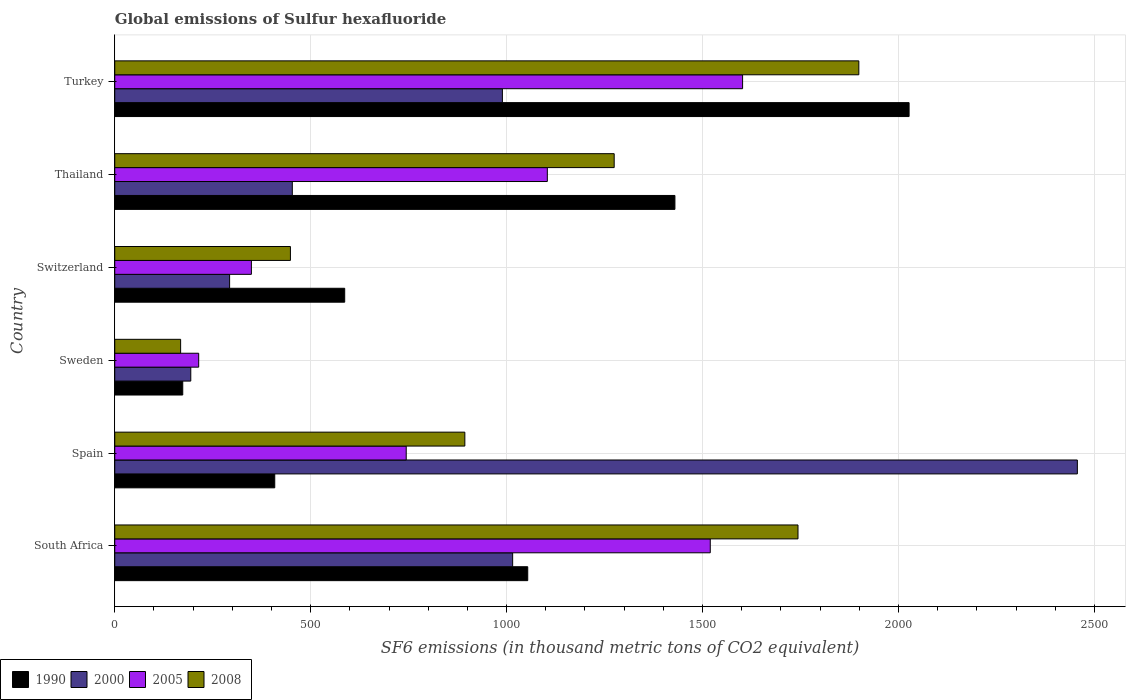How many different coloured bars are there?
Offer a very short reply. 4. Are the number of bars per tick equal to the number of legend labels?
Keep it short and to the point. Yes. How many bars are there on the 3rd tick from the bottom?
Keep it short and to the point. 4. What is the label of the 2nd group of bars from the top?
Your response must be concise. Thailand. In how many cases, is the number of bars for a given country not equal to the number of legend labels?
Offer a very short reply. 0. What is the global emissions of Sulfur hexafluoride in 2000 in Turkey?
Provide a short and direct response. 989.2. Across all countries, what is the maximum global emissions of Sulfur hexafluoride in 2000?
Your answer should be compact. 2456.5. Across all countries, what is the minimum global emissions of Sulfur hexafluoride in 2000?
Offer a terse response. 194. In which country was the global emissions of Sulfur hexafluoride in 2008 minimum?
Offer a terse response. Sweden. What is the total global emissions of Sulfur hexafluoride in 2008 in the graph?
Your response must be concise. 6426.7. What is the difference between the global emissions of Sulfur hexafluoride in 2008 in Thailand and that in Turkey?
Your response must be concise. -624.3. What is the difference between the global emissions of Sulfur hexafluoride in 2008 in Sweden and the global emissions of Sulfur hexafluoride in 1990 in Spain?
Make the answer very short. -240.2. What is the average global emissions of Sulfur hexafluoride in 2008 per country?
Make the answer very short. 1071.12. What is the difference between the global emissions of Sulfur hexafluoride in 1990 and global emissions of Sulfur hexafluoride in 2005 in Thailand?
Offer a very short reply. 325.6. In how many countries, is the global emissions of Sulfur hexafluoride in 2008 greater than 1800 thousand metric tons?
Your response must be concise. 1. What is the ratio of the global emissions of Sulfur hexafluoride in 1990 in Spain to that in Thailand?
Provide a short and direct response. 0.29. Is the global emissions of Sulfur hexafluoride in 2000 in South Africa less than that in Switzerland?
Offer a terse response. No. Is the difference between the global emissions of Sulfur hexafluoride in 1990 in Spain and Sweden greater than the difference between the global emissions of Sulfur hexafluoride in 2005 in Spain and Sweden?
Your answer should be very brief. No. What is the difference between the highest and the second highest global emissions of Sulfur hexafluoride in 1990?
Give a very brief answer. 597.6. What is the difference between the highest and the lowest global emissions of Sulfur hexafluoride in 2005?
Your response must be concise. 1388. Is the sum of the global emissions of Sulfur hexafluoride in 2000 in Thailand and Turkey greater than the maximum global emissions of Sulfur hexafluoride in 2008 across all countries?
Your response must be concise. No. Is it the case that in every country, the sum of the global emissions of Sulfur hexafluoride in 1990 and global emissions of Sulfur hexafluoride in 2005 is greater than the sum of global emissions of Sulfur hexafluoride in 2000 and global emissions of Sulfur hexafluoride in 2008?
Your answer should be compact. No. What does the 2nd bar from the top in Sweden represents?
Provide a short and direct response. 2005. Is it the case that in every country, the sum of the global emissions of Sulfur hexafluoride in 2000 and global emissions of Sulfur hexafluoride in 1990 is greater than the global emissions of Sulfur hexafluoride in 2005?
Offer a very short reply. Yes. Are all the bars in the graph horizontal?
Make the answer very short. Yes. Are the values on the major ticks of X-axis written in scientific E-notation?
Your answer should be very brief. No. Does the graph contain any zero values?
Offer a terse response. No. How are the legend labels stacked?
Offer a terse response. Horizontal. What is the title of the graph?
Provide a succinct answer. Global emissions of Sulfur hexafluoride. Does "1975" appear as one of the legend labels in the graph?
Keep it short and to the point. No. What is the label or title of the X-axis?
Your answer should be compact. SF6 emissions (in thousand metric tons of CO2 equivalent). What is the label or title of the Y-axis?
Ensure brevity in your answer.  Country. What is the SF6 emissions (in thousand metric tons of CO2 equivalent) in 1990 in South Africa?
Your answer should be very brief. 1053.9. What is the SF6 emissions (in thousand metric tons of CO2 equivalent) of 2000 in South Africa?
Make the answer very short. 1015.4. What is the SF6 emissions (in thousand metric tons of CO2 equivalent) of 2005 in South Africa?
Provide a succinct answer. 1519.7. What is the SF6 emissions (in thousand metric tons of CO2 equivalent) in 2008 in South Africa?
Ensure brevity in your answer.  1743.6. What is the SF6 emissions (in thousand metric tons of CO2 equivalent) of 1990 in Spain?
Ensure brevity in your answer.  408.3. What is the SF6 emissions (in thousand metric tons of CO2 equivalent) of 2000 in Spain?
Give a very brief answer. 2456.5. What is the SF6 emissions (in thousand metric tons of CO2 equivalent) of 2005 in Spain?
Keep it short and to the point. 743.8. What is the SF6 emissions (in thousand metric tons of CO2 equivalent) in 2008 in Spain?
Offer a terse response. 893.4. What is the SF6 emissions (in thousand metric tons of CO2 equivalent) of 1990 in Sweden?
Offer a terse response. 173.5. What is the SF6 emissions (in thousand metric tons of CO2 equivalent) in 2000 in Sweden?
Give a very brief answer. 194. What is the SF6 emissions (in thousand metric tons of CO2 equivalent) in 2005 in Sweden?
Keep it short and to the point. 214.2. What is the SF6 emissions (in thousand metric tons of CO2 equivalent) of 2008 in Sweden?
Your answer should be very brief. 168.1. What is the SF6 emissions (in thousand metric tons of CO2 equivalent) in 1990 in Switzerland?
Provide a short and direct response. 586.8. What is the SF6 emissions (in thousand metric tons of CO2 equivalent) in 2000 in Switzerland?
Your answer should be very brief. 293.1. What is the SF6 emissions (in thousand metric tons of CO2 equivalent) in 2005 in Switzerland?
Provide a short and direct response. 348.7. What is the SF6 emissions (in thousand metric tons of CO2 equivalent) of 2008 in Switzerland?
Make the answer very short. 448.3. What is the SF6 emissions (in thousand metric tons of CO2 equivalent) of 1990 in Thailand?
Keep it short and to the point. 1429.5. What is the SF6 emissions (in thousand metric tons of CO2 equivalent) of 2000 in Thailand?
Your response must be concise. 453.1. What is the SF6 emissions (in thousand metric tons of CO2 equivalent) in 2005 in Thailand?
Your response must be concise. 1103.9. What is the SF6 emissions (in thousand metric tons of CO2 equivalent) of 2008 in Thailand?
Your answer should be compact. 1274.5. What is the SF6 emissions (in thousand metric tons of CO2 equivalent) of 1990 in Turkey?
Your answer should be very brief. 2027.1. What is the SF6 emissions (in thousand metric tons of CO2 equivalent) of 2000 in Turkey?
Ensure brevity in your answer.  989.2. What is the SF6 emissions (in thousand metric tons of CO2 equivalent) of 2005 in Turkey?
Your answer should be compact. 1602.2. What is the SF6 emissions (in thousand metric tons of CO2 equivalent) in 2008 in Turkey?
Your response must be concise. 1898.8. Across all countries, what is the maximum SF6 emissions (in thousand metric tons of CO2 equivalent) of 1990?
Make the answer very short. 2027.1. Across all countries, what is the maximum SF6 emissions (in thousand metric tons of CO2 equivalent) in 2000?
Provide a short and direct response. 2456.5. Across all countries, what is the maximum SF6 emissions (in thousand metric tons of CO2 equivalent) of 2005?
Ensure brevity in your answer.  1602.2. Across all countries, what is the maximum SF6 emissions (in thousand metric tons of CO2 equivalent) in 2008?
Your answer should be very brief. 1898.8. Across all countries, what is the minimum SF6 emissions (in thousand metric tons of CO2 equivalent) of 1990?
Provide a short and direct response. 173.5. Across all countries, what is the minimum SF6 emissions (in thousand metric tons of CO2 equivalent) in 2000?
Provide a succinct answer. 194. Across all countries, what is the minimum SF6 emissions (in thousand metric tons of CO2 equivalent) in 2005?
Your answer should be very brief. 214.2. Across all countries, what is the minimum SF6 emissions (in thousand metric tons of CO2 equivalent) in 2008?
Keep it short and to the point. 168.1. What is the total SF6 emissions (in thousand metric tons of CO2 equivalent) of 1990 in the graph?
Provide a short and direct response. 5679.1. What is the total SF6 emissions (in thousand metric tons of CO2 equivalent) in 2000 in the graph?
Provide a succinct answer. 5401.3. What is the total SF6 emissions (in thousand metric tons of CO2 equivalent) of 2005 in the graph?
Provide a succinct answer. 5532.5. What is the total SF6 emissions (in thousand metric tons of CO2 equivalent) in 2008 in the graph?
Your answer should be very brief. 6426.7. What is the difference between the SF6 emissions (in thousand metric tons of CO2 equivalent) of 1990 in South Africa and that in Spain?
Give a very brief answer. 645.6. What is the difference between the SF6 emissions (in thousand metric tons of CO2 equivalent) of 2000 in South Africa and that in Spain?
Provide a short and direct response. -1441.1. What is the difference between the SF6 emissions (in thousand metric tons of CO2 equivalent) of 2005 in South Africa and that in Spain?
Make the answer very short. 775.9. What is the difference between the SF6 emissions (in thousand metric tons of CO2 equivalent) in 2008 in South Africa and that in Spain?
Ensure brevity in your answer.  850.2. What is the difference between the SF6 emissions (in thousand metric tons of CO2 equivalent) of 1990 in South Africa and that in Sweden?
Give a very brief answer. 880.4. What is the difference between the SF6 emissions (in thousand metric tons of CO2 equivalent) in 2000 in South Africa and that in Sweden?
Offer a very short reply. 821.4. What is the difference between the SF6 emissions (in thousand metric tons of CO2 equivalent) in 2005 in South Africa and that in Sweden?
Your response must be concise. 1305.5. What is the difference between the SF6 emissions (in thousand metric tons of CO2 equivalent) of 2008 in South Africa and that in Sweden?
Make the answer very short. 1575.5. What is the difference between the SF6 emissions (in thousand metric tons of CO2 equivalent) of 1990 in South Africa and that in Switzerland?
Your response must be concise. 467.1. What is the difference between the SF6 emissions (in thousand metric tons of CO2 equivalent) of 2000 in South Africa and that in Switzerland?
Offer a terse response. 722.3. What is the difference between the SF6 emissions (in thousand metric tons of CO2 equivalent) in 2005 in South Africa and that in Switzerland?
Your response must be concise. 1171. What is the difference between the SF6 emissions (in thousand metric tons of CO2 equivalent) of 2008 in South Africa and that in Switzerland?
Ensure brevity in your answer.  1295.3. What is the difference between the SF6 emissions (in thousand metric tons of CO2 equivalent) of 1990 in South Africa and that in Thailand?
Your answer should be very brief. -375.6. What is the difference between the SF6 emissions (in thousand metric tons of CO2 equivalent) in 2000 in South Africa and that in Thailand?
Your answer should be compact. 562.3. What is the difference between the SF6 emissions (in thousand metric tons of CO2 equivalent) of 2005 in South Africa and that in Thailand?
Keep it short and to the point. 415.8. What is the difference between the SF6 emissions (in thousand metric tons of CO2 equivalent) of 2008 in South Africa and that in Thailand?
Make the answer very short. 469.1. What is the difference between the SF6 emissions (in thousand metric tons of CO2 equivalent) in 1990 in South Africa and that in Turkey?
Your answer should be compact. -973.2. What is the difference between the SF6 emissions (in thousand metric tons of CO2 equivalent) of 2000 in South Africa and that in Turkey?
Keep it short and to the point. 26.2. What is the difference between the SF6 emissions (in thousand metric tons of CO2 equivalent) in 2005 in South Africa and that in Turkey?
Offer a very short reply. -82.5. What is the difference between the SF6 emissions (in thousand metric tons of CO2 equivalent) of 2008 in South Africa and that in Turkey?
Provide a succinct answer. -155.2. What is the difference between the SF6 emissions (in thousand metric tons of CO2 equivalent) in 1990 in Spain and that in Sweden?
Ensure brevity in your answer.  234.8. What is the difference between the SF6 emissions (in thousand metric tons of CO2 equivalent) in 2000 in Spain and that in Sweden?
Your answer should be very brief. 2262.5. What is the difference between the SF6 emissions (in thousand metric tons of CO2 equivalent) of 2005 in Spain and that in Sweden?
Offer a very short reply. 529.6. What is the difference between the SF6 emissions (in thousand metric tons of CO2 equivalent) in 2008 in Spain and that in Sweden?
Offer a very short reply. 725.3. What is the difference between the SF6 emissions (in thousand metric tons of CO2 equivalent) of 1990 in Spain and that in Switzerland?
Your response must be concise. -178.5. What is the difference between the SF6 emissions (in thousand metric tons of CO2 equivalent) in 2000 in Spain and that in Switzerland?
Keep it short and to the point. 2163.4. What is the difference between the SF6 emissions (in thousand metric tons of CO2 equivalent) of 2005 in Spain and that in Switzerland?
Give a very brief answer. 395.1. What is the difference between the SF6 emissions (in thousand metric tons of CO2 equivalent) of 2008 in Spain and that in Switzerland?
Ensure brevity in your answer.  445.1. What is the difference between the SF6 emissions (in thousand metric tons of CO2 equivalent) in 1990 in Spain and that in Thailand?
Provide a succinct answer. -1021.2. What is the difference between the SF6 emissions (in thousand metric tons of CO2 equivalent) of 2000 in Spain and that in Thailand?
Provide a succinct answer. 2003.4. What is the difference between the SF6 emissions (in thousand metric tons of CO2 equivalent) in 2005 in Spain and that in Thailand?
Your response must be concise. -360.1. What is the difference between the SF6 emissions (in thousand metric tons of CO2 equivalent) in 2008 in Spain and that in Thailand?
Your answer should be compact. -381.1. What is the difference between the SF6 emissions (in thousand metric tons of CO2 equivalent) of 1990 in Spain and that in Turkey?
Your answer should be very brief. -1618.8. What is the difference between the SF6 emissions (in thousand metric tons of CO2 equivalent) in 2000 in Spain and that in Turkey?
Provide a short and direct response. 1467.3. What is the difference between the SF6 emissions (in thousand metric tons of CO2 equivalent) in 2005 in Spain and that in Turkey?
Keep it short and to the point. -858.4. What is the difference between the SF6 emissions (in thousand metric tons of CO2 equivalent) in 2008 in Spain and that in Turkey?
Provide a short and direct response. -1005.4. What is the difference between the SF6 emissions (in thousand metric tons of CO2 equivalent) of 1990 in Sweden and that in Switzerland?
Keep it short and to the point. -413.3. What is the difference between the SF6 emissions (in thousand metric tons of CO2 equivalent) in 2000 in Sweden and that in Switzerland?
Your response must be concise. -99.1. What is the difference between the SF6 emissions (in thousand metric tons of CO2 equivalent) of 2005 in Sweden and that in Switzerland?
Give a very brief answer. -134.5. What is the difference between the SF6 emissions (in thousand metric tons of CO2 equivalent) in 2008 in Sweden and that in Switzerland?
Give a very brief answer. -280.2. What is the difference between the SF6 emissions (in thousand metric tons of CO2 equivalent) of 1990 in Sweden and that in Thailand?
Make the answer very short. -1256. What is the difference between the SF6 emissions (in thousand metric tons of CO2 equivalent) of 2000 in Sweden and that in Thailand?
Offer a terse response. -259.1. What is the difference between the SF6 emissions (in thousand metric tons of CO2 equivalent) of 2005 in Sweden and that in Thailand?
Make the answer very short. -889.7. What is the difference between the SF6 emissions (in thousand metric tons of CO2 equivalent) of 2008 in Sweden and that in Thailand?
Your answer should be very brief. -1106.4. What is the difference between the SF6 emissions (in thousand metric tons of CO2 equivalent) in 1990 in Sweden and that in Turkey?
Ensure brevity in your answer.  -1853.6. What is the difference between the SF6 emissions (in thousand metric tons of CO2 equivalent) of 2000 in Sweden and that in Turkey?
Your answer should be compact. -795.2. What is the difference between the SF6 emissions (in thousand metric tons of CO2 equivalent) of 2005 in Sweden and that in Turkey?
Your answer should be compact. -1388. What is the difference between the SF6 emissions (in thousand metric tons of CO2 equivalent) of 2008 in Sweden and that in Turkey?
Your answer should be compact. -1730.7. What is the difference between the SF6 emissions (in thousand metric tons of CO2 equivalent) of 1990 in Switzerland and that in Thailand?
Keep it short and to the point. -842.7. What is the difference between the SF6 emissions (in thousand metric tons of CO2 equivalent) of 2000 in Switzerland and that in Thailand?
Your answer should be compact. -160. What is the difference between the SF6 emissions (in thousand metric tons of CO2 equivalent) in 2005 in Switzerland and that in Thailand?
Offer a very short reply. -755.2. What is the difference between the SF6 emissions (in thousand metric tons of CO2 equivalent) in 2008 in Switzerland and that in Thailand?
Your response must be concise. -826.2. What is the difference between the SF6 emissions (in thousand metric tons of CO2 equivalent) in 1990 in Switzerland and that in Turkey?
Your answer should be very brief. -1440.3. What is the difference between the SF6 emissions (in thousand metric tons of CO2 equivalent) in 2000 in Switzerland and that in Turkey?
Offer a very short reply. -696.1. What is the difference between the SF6 emissions (in thousand metric tons of CO2 equivalent) of 2005 in Switzerland and that in Turkey?
Give a very brief answer. -1253.5. What is the difference between the SF6 emissions (in thousand metric tons of CO2 equivalent) of 2008 in Switzerland and that in Turkey?
Provide a short and direct response. -1450.5. What is the difference between the SF6 emissions (in thousand metric tons of CO2 equivalent) of 1990 in Thailand and that in Turkey?
Make the answer very short. -597.6. What is the difference between the SF6 emissions (in thousand metric tons of CO2 equivalent) of 2000 in Thailand and that in Turkey?
Offer a very short reply. -536.1. What is the difference between the SF6 emissions (in thousand metric tons of CO2 equivalent) in 2005 in Thailand and that in Turkey?
Give a very brief answer. -498.3. What is the difference between the SF6 emissions (in thousand metric tons of CO2 equivalent) of 2008 in Thailand and that in Turkey?
Ensure brevity in your answer.  -624.3. What is the difference between the SF6 emissions (in thousand metric tons of CO2 equivalent) of 1990 in South Africa and the SF6 emissions (in thousand metric tons of CO2 equivalent) of 2000 in Spain?
Give a very brief answer. -1402.6. What is the difference between the SF6 emissions (in thousand metric tons of CO2 equivalent) in 1990 in South Africa and the SF6 emissions (in thousand metric tons of CO2 equivalent) in 2005 in Spain?
Give a very brief answer. 310.1. What is the difference between the SF6 emissions (in thousand metric tons of CO2 equivalent) of 1990 in South Africa and the SF6 emissions (in thousand metric tons of CO2 equivalent) of 2008 in Spain?
Your answer should be very brief. 160.5. What is the difference between the SF6 emissions (in thousand metric tons of CO2 equivalent) of 2000 in South Africa and the SF6 emissions (in thousand metric tons of CO2 equivalent) of 2005 in Spain?
Keep it short and to the point. 271.6. What is the difference between the SF6 emissions (in thousand metric tons of CO2 equivalent) of 2000 in South Africa and the SF6 emissions (in thousand metric tons of CO2 equivalent) of 2008 in Spain?
Your answer should be very brief. 122. What is the difference between the SF6 emissions (in thousand metric tons of CO2 equivalent) of 2005 in South Africa and the SF6 emissions (in thousand metric tons of CO2 equivalent) of 2008 in Spain?
Your answer should be very brief. 626.3. What is the difference between the SF6 emissions (in thousand metric tons of CO2 equivalent) of 1990 in South Africa and the SF6 emissions (in thousand metric tons of CO2 equivalent) of 2000 in Sweden?
Make the answer very short. 859.9. What is the difference between the SF6 emissions (in thousand metric tons of CO2 equivalent) of 1990 in South Africa and the SF6 emissions (in thousand metric tons of CO2 equivalent) of 2005 in Sweden?
Offer a very short reply. 839.7. What is the difference between the SF6 emissions (in thousand metric tons of CO2 equivalent) of 1990 in South Africa and the SF6 emissions (in thousand metric tons of CO2 equivalent) of 2008 in Sweden?
Your answer should be compact. 885.8. What is the difference between the SF6 emissions (in thousand metric tons of CO2 equivalent) in 2000 in South Africa and the SF6 emissions (in thousand metric tons of CO2 equivalent) in 2005 in Sweden?
Offer a terse response. 801.2. What is the difference between the SF6 emissions (in thousand metric tons of CO2 equivalent) in 2000 in South Africa and the SF6 emissions (in thousand metric tons of CO2 equivalent) in 2008 in Sweden?
Provide a short and direct response. 847.3. What is the difference between the SF6 emissions (in thousand metric tons of CO2 equivalent) of 2005 in South Africa and the SF6 emissions (in thousand metric tons of CO2 equivalent) of 2008 in Sweden?
Provide a short and direct response. 1351.6. What is the difference between the SF6 emissions (in thousand metric tons of CO2 equivalent) of 1990 in South Africa and the SF6 emissions (in thousand metric tons of CO2 equivalent) of 2000 in Switzerland?
Keep it short and to the point. 760.8. What is the difference between the SF6 emissions (in thousand metric tons of CO2 equivalent) of 1990 in South Africa and the SF6 emissions (in thousand metric tons of CO2 equivalent) of 2005 in Switzerland?
Your answer should be very brief. 705.2. What is the difference between the SF6 emissions (in thousand metric tons of CO2 equivalent) of 1990 in South Africa and the SF6 emissions (in thousand metric tons of CO2 equivalent) of 2008 in Switzerland?
Make the answer very short. 605.6. What is the difference between the SF6 emissions (in thousand metric tons of CO2 equivalent) of 2000 in South Africa and the SF6 emissions (in thousand metric tons of CO2 equivalent) of 2005 in Switzerland?
Provide a short and direct response. 666.7. What is the difference between the SF6 emissions (in thousand metric tons of CO2 equivalent) in 2000 in South Africa and the SF6 emissions (in thousand metric tons of CO2 equivalent) in 2008 in Switzerland?
Offer a very short reply. 567.1. What is the difference between the SF6 emissions (in thousand metric tons of CO2 equivalent) in 2005 in South Africa and the SF6 emissions (in thousand metric tons of CO2 equivalent) in 2008 in Switzerland?
Make the answer very short. 1071.4. What is the difference between the SF6 emissions (in thousand metric tons of CO2 equivalent) of 1990 in South Africa and the SF6 emissions (in thousand metric tons of CO2 equivalent) of 2000 in Thailand?
Offer a terse response. 600.8. What is the difference between the SF6 emissions (in thousand metric tons of CO2 equivalent) of 1990 in South Africa and the SF6 emissions (in thousand metric tons of CO2 equivalent) of 2008 in Thailand?
Provide a short and direct response. -220.6. What is the difference between the SF6 emissions (in thousand metric tons of CO2 equivalent) in 2000 in South Africa and the SF6 emissions (in thousand metric tons of CO2 equivalent) in 2005 in Thailand?
Offer a terse response. -88.5. What is the difference between the SF6 emissions (in thousand metric tons of CO2 equivalent) in 2000 in South Africa and the SF6 emissions (in thousand metric tons of CO2 equivalent) in 2008 in Thailand?
Ensure brevity in your answer.  -259.1. What is the difference between the SF6 emissions (in thousand metric tons of CO2 equivalent) of 2005 in South Africa and the SF6 emissions (in thousand metric tons of CO2 equivalent) of 2008 in Thailand?
Provide a succinct answer. 245.2. What is the difference between the SF6 emissions (in thousand metric tons of CO2 equivalent) of 1990 in South Africa and the SF6 emissions (in thousand metric tons of CO2 equivalent) of 2000 in Turkey?
Your answer should be very brief. 64.7. What is the difference between the SF6 emissions (in thousand metric tons of CO2 equivalent) of 1990 in South Africa and the SF6 emissions (in thousand metric tons of CO2 equivalent) of 2005 in Turkey?
Provide a succinct answer. -548.3. What is the difference between the SF6 emissions (in thousand metric tons of CO2 equivalent) of 1990 in South Africa and the SF6 emissions (in thousand metric tons of CO2 equivalent) of 2008 in Turkey?
Provide a short and direct response. -844.9. What is the difference between the SF6 emissions (in thousand metric tons of CO2 equivalent) of 2000 in South Africa and the SF6 emissions (in thousand metric tons of CO2 equivalent) of 2005 in Turkey?
Provide a succinct answer. -586.8. What is the difference between the SF6 emissions (in thousand metric tons of CO2 equivalent) of 2000 in South Africa and the SF6 emissions (in thousand metric tons of CO2 equivalent) of 2008 in Turkey?
Make the answer very short. -883.4. What is the difference between the SF6 emissions (in thousand metric tons of CO2 equivalent) in 2005 in South Africa and the SF6 emissions (in thousand metric tons of CO2 equivalent) in 2008 in Turkey?
Your answer should be compact. -379.1. What is the difference between the SF6 emissions (in thousand metric tons of CO2 equivalent) in 1990 in Spain and the SF6 emissions (in thousand metric tons of CO2 equivalent) in 2000 in Sweden?
Your answer should be compact. 214.3. What is the difference between the SF6 emissions (in thousand metric tons of CO2 equivalent) of 1990 in Spain and the SF6 emissions (in thousand metric tons of CO2 equivalent) of 2005 in Sweden?
Offer a very short reply. 194.1. What is the difference between the SF6 emissions (in thousand metric tons of CO2 equivalent) of 1990 in Spain and the SF6 emissions (in thousand metric tons of CO2 equivalent) of 2008 in Sweden?
Offer a very short reply. 240.2. What is the difference between the SF6 emissions (in thousand metric tons of CO2 equivalent) of 2000 in Spain and the SF6 emissions (in thousand metric tons of CO2 equivalent) of 2005 in Sweden?
Provide a short and direct response. 2242.3. What is the difference between the SF6 emissions (in thousand metric tons of CO2 equivalent) in 2000 in Spain and the SF6 emissions (in thousand metric tons of CO2 equivalent) in 2008 in Sweden?
Your answer should be compact. 2288.4. What is the difference between the SF6 emissions (in thousand metric tons of CO2 equivalent) of 2005 in Spain and the SF6 emissions (in thousand metric tons of CO2 equivalent) of 2008 in Sweden?
Your answer should be compact. 575.7. What is the difference between the SF6 emissions (in thousand metric tons of CO2 equivalent) of 1990 in Spain and the SF6 emissions (in thousand metric tons of CO2 equivalent) of 2000 in Switzerland?
Give a very brief answer. 115.2. What is the difference between the SF6 emissions (in thousand metric tons of CO2 equivalent) in 1990 in Spain and the SF6 emissions (in thousand metric tons of CO2 equivalent) in 2005 in Switzerland?
Give a very brief answer. 59.6. What is the difference between the SF6 emissions (in thousand metric tons of CO2 equivalent) of 2000 in Spain and the SF6 emissions (in thousand metric tons of CO2 equivalent) of 2005 in Switzerland?
Give a very brief answer. 2107.8. What is the difference between the SF6 emissions (in thousand metric tons of CO2 equivalent) of 2000 in Spain and the SF6 emissions (in thousand metric tons of CO2 equivalent) of 2008 in Switzerland?
Your answer should be compact. 2008.2. What is the difference between the SF6 emissions (in thousand metric tons of CO2 equivalent) of 2005 in Spain and the SF6 emissions (in thousand metric tons of CO2 equivalent) of 2008 in Switzerland?
Keep it short and to the point. 295.5. What is the difference between the SF6 emissions (in thousand metric tons of CO2 equivalent) of 1990 in Spain and the SF6 emissions (in thousand metric tons of CO2 equivalent) of 2000 in Thailand?
Offer a terse response. -44.8. What is the difference between the SF6 emissions (in thousand metric tons of CO2 equivalent) of 1990 in Spain and the SF6 emissions (in thousand metric tons of CO2 equivalent) of 2005 in Thailand?
Make the answer very short. -695.6. What is the difference between the SF6 emissions (in thousand metric tons of CO2 equivalent) of 1990 in Spain and the SF6 emissions (in thousand metric tons of CO2 equivalent) of 2008 in Thailand?
Offer a very short reply. -866.2. What is the difference between the SF6 emissions (in thousand metric tons of CO2 equivalent) in 2000 in Spain and the SF6 emissions (in thousand metric tons of CO2 equivalent) in 2005 in Thailand?
Give a very brief answer. 1352.6. What is the difference between the SF6 emissions (in thousand metric tons of CO2 equivalent) in 2000 in Spain and the SF6 emissions (in thousand metric tons of CO2 equivalent) in 2008 in Thailand?
Your answer should be very brief. 1182. What is the difference between the SF6 emissions (in thousand metric tons of CO2 equivalent) of 2005 in Spain and the SF6 emissions (in thousand metric tons of CO2 equivalent) of 2008 in Thailand?
Provide a short and direct response. -530.7. What is the difference between the SF6 emissions (in thousand metric tons of CO2 equivalent) in 1990 in Spain and the SF6 emissions (in thousand metric tons of CO2 equivalent) in 2000 in Turkey?
Keep it short and to the point. -580.9. What is the difference between the SF6 emissions (in thousand metric tons of CO2 equivalent) in 1990 in Spain and the SF6 emissions (in thousand metric tons of CO2 equivalent) in 2005 in Turkey?
Provide a succinct answer. -1193.9. What is the difference between the SF6 emissions (in thousand metric tons of CO2 equivalent) in 1990 in Spain and the SF6 emissions (in thousand metric tons of CO2 equivalent) in 2008 in Turkey?
Your response must be concise. -1490.5. What is the difference between the SF6 emissions (in thousand metric tons of CO2 equivalent) of 2000 in Spain and the SF6 emissions (in thousand metric tons of CO2 equivalent) of 2005 in Turkey?
Your answer should be very brief. 854.3. What is the difference between the SF6 emissions (in thousand metric tons of CO2 equivalent) of 2000 in Spain and the SF6 emissions (in thousand metric tons of CO2 equivalent) of 2008 in Turkey?
Give a very brief answer. 557.7. What is the difference between the SF6 emissions (in thousand metric tons of CO2 equivalent) in 2005 in Spain and the SF6 emissions (in thousand metric tons of CO2 equivalent) in 2008 in Turkey?
Make the answer very short. -1155. What is the difference between the SF6 emissions (in thousand metric tons of CO2 equivalent) in 1990 in Sweden and the SF6 emissions (in thousand metric tons of CO2 equivalent) in 2000 in Switzerland?
Provide a short and direct response. -119.6. What is the difference between the SF6 emissions (in thousand metric tons of CO2 equivalent) in 1990 in Sweden and the SF6 emissions (in thousand metric tons of CO2 equivalent) in 2005 in Switzerland?
Ensure brevity in your answer.  -175.2. What is the difference between the SF6 emissions (in thousand metric tons of CO2 equivalent) of 1990 in Sweden and the SF6 emissions (in thousand metric tons of CO2 equivalent) of 2008 in Switzerland?
Keep it short and to the point. -274.8. What is the difference between the SF6 emissions (in thousand metric tons of CO2 equivalent) in 2000 in Sweden and the SF6 emissions (in thousand metric tons of CO2 equivalent) in 2005 in Switzerland?
Provide a succinct answer. -154.7. What is the difference between the SF6 emissions (in thousand metric tons of CO2 equivalent) of 2000 in Sweden and the SF6 emissions (in thousand metric tons of CO2 equivalent) of 2008 in Switzerland?
Make the answer very short. -254.3. What is the difference between the SF6 emissions (in thousand metric tons of CO2 equivalent) in 2005 in Sweden and the SF6 emissions (in thousand metric tons of CO2 equivalent) in 2008 in Switzerland?
Offer a terse response. -234.1. What is the difference between the SF6 emissions (in thousand metric tons of CO2 equivalent) of 1990 in Sweden and the SF6 emissions (in thousand metric tons of CO2 equivalent) of 2000 in Thailand?
Make the answer very short. -279.6. What is the difference between the SF6 emissions (in thousand metric tons of CO2 equivalent) in 1990 in Sweden and the SF6 emissions (in thousand metric tons of CO2 equivalent) in 2005 in Thailand?
Ensure brevity in your answer.  -930.4. What is the difference between the SF6 emissions (in thousand metric tons of CO2 equivalent) of 1990 in Sweden and the SF6 emissions (in thousand metric tons of CO2 equivalent) of 2008 in Thailand?
Provide a short and direct response. -1101. What is the difference between the SF6 emissions (in thousand metric tons of CO2 equivalent) in 2000 in Sweden and the SF6 emissions (in thousand metric tons of CO2 equivalent) in 2005 in Thailand?
Provide a short and direct response. -909.9. What is the difference between the SF6 emissions (in thousand metric tons of CO2 equivalent) in 2000 in Sweden and the SF6 emissions (in thousand metric tons of CO2 equivalent) in 2008 in Thailand?
Your answer should be very brief. -1080.5. What is the difference between the SF6 emissions (in thousand metric tons of CO2 equivalent) of 2005 in Sweden and the SF6 emissions (in thousand metric tons of CO2 equivalent) of 2008 in Thailand?
Give a very brief answer. -1060.3. What is the difference between the SF6 emissions (in thousand metric tons of CO2 equivalent) of 1990 in Sweden and the SF6 emissions (in thousand metric tons of CO2 equivalent) of 2000 in Turkey?
Your response must be concise. -815.7. What is the difference between the SF6 emissions (in thousand metric tons of CO2 equivalent) in 1990 in Sweden and the SF6 emissions (in thousand metric tons of CO2 equivalent) in 2005 in Turkey?
Your answer should be very brief. -1428.7. What is the difference between the SF6 emissions (in thousand metric tons of CO2 equivalent) of 1990 in Sweden and the SF6 emissions (in thousand metric tons of CO2 equivalent) of 2008 in Turkey?
Ensure brevity in your answer.  -1725.3. What is the difference between the SF6 emissions (in thousand metric tons of CO2 equivalent) of 2000 in Sweden and the SF6 emissions (in thousand metric tons of CO2 equivalent) of 2005 in Turkey?
Keep it short and to the point. -1408.2. What is the difference between the SF6 emissions (in thousand metric tons of CO2 equivalent) in 2000 in Sweden and the SF6 emissions (in thousand metric tons of CO2 equivalent) in 2008 in Turkey?
Your answer should be compact. -1704.8. What is the difference between the SF6 emissions (in thousand metric tons of CO2 equivalent) of 2005 in Sweden and the SF6 emissions (in thousand metric tons of CO2 equivalent) of 2008 in Turkey?
Your response must be concise. -1684.6. What is the difference between the SF6 emissions (in thousand metric tons of CO2 equivalent) in 1990 in Switzerland and the SF6 emissions (in thousand metric tons of CO2 equivalent) in 2000 in Thailand?
Ensure brevity in your answer.  133.7. What is the difference between the SF6 emissions (in thousand metric tons of CO2 equivalent) in 1990 in Switzerland and the SF6 emissions (in thousand metric tons of CO2 equivalent) in 2005 in Thailand?
Provide a short and direct response. -517.1. What is the difference between the SF6 emissions (in thousand metric tons of CO2 equivalent) in 1990 in Switzerland and the SF6 emissions (in thousand metric tons of CO2 equivalent) in 2008 in Thailand?
Ensure brevity in your answer.  -687.7. What is the difference between the SF6 emissions (in thousand metric tons of CO2 equivalent) in 2000 in Switzerland and the SF6 emissions (in thousand metric tons of CO2 equivalent) in 2005 in Thailand?
Offer a very short reply. -810.8. What is the difference between the SF6 emissions (in thousand metric tons of CO2 equivalent) in 2000 in Switzerland and the SF6 emissions (in thousand metric tons of CO2 equivalent) in 2008 in Thailand?
Keep it short and to the point. -981.4. What is the difference between the SF6 emissions (in thousand metric tons of CO2 equivalent) in 2005 in Switzerland and the SF6 emissions (in thousand metric tons of CO2 equivalent) in 2008 in Thailand?
Provide a succinct answer. -925.8. What is the difference between the SF6 emissions (in thousand metric tons of CO2 equivalent) of 1990 in Switzerland and the SF6 emissions (in thousand metric tons of CO2 equivalent) of 2000 in Turkey?
Your response must be concise. -402.4. What is the difference between the SF6 emissions (in thousand metric tons of CO2 equivalent) in 1990 in Switzerland and the SF6 emissions (in thousand metric tons of CO2 equivalent) in 2005 in Turkey?
Your response must be concise. -1015.4. What is the difference between the SF6 emissions (in thousand metric tons of CO2 equivalent) of 1990 in Switzerland and the SF6 emissions (in thousand metric tons of CO2 equivalent) of 2008 in Turkey?
Keep it short and to the point. -1312. What is the difference between the SF6 emissions (in thousand metric tons of CO2 equivalent) of 2000 in Switzerland and the SF6 emissions (in thousand metric tons of CO2 equivalent) of 2005 in Turkey?
Ensure brevity in your answer.  -1309.1. What is the difference between the SF6 emissions (in thousand metric tons of CO2 equivalent) of 2000 in Switzerland and the SF6 emissions (in thousand metric tons of CO2 equivalent) of 2008 in Turkey?
Offer a terse response. -1605.7. What is the difference between the SF6 emissions (in thousand metric tons of CO2 equivalent) in 2005 in Switzerland and the SF6 emissions (in thousand metric tons of CO2 equivalent) in 2008 in Turkey?
Provide a short and direct response. -1550.1. What is the difference between the SF6 emissions (in thousand metric tons of CO2 equivalent) of 1990 in Thailand and the SF6 emissions (in thousand metric tons of CO2 equivalent) of 2000 in Turkey?
Your answer should be very brief. 440.3. What is the difference between the SF6 emissions (in thousand metric tons of CO2 equivalent) of 1990 in Thailand and the SF6 emissions (in thousand metric tons of CO2 equivalent) of 2005 in Turkey?
Your response must be concise. -172.7. What is the difference between the SF6 emissions (in thousand metric tons of CO2 equivalent) of 1990 in Thailand and the SF6 emissions (in thousand metric tons of CO2 equivalent) of 2008 in Turkey?
Provide a succinct answer. -469.3. What is the difference between the SF6 emissions (in thousand metric tons of CO2 equivalent) in 2000 in Thailand and the SF6 emissions (in thousand metric tons of CO2 equivalent) in 2005 in Turkey?
Keep it short and to the point. -1149.1. What is the difference between the SF6 emissions (in thousand metric tons of CO2 equivalent) of 2000 in Thailand and the SF6 emissions (in thousand metric tons of CO2 equivalent) of 2008 in Turkey?
Provide a succinct answer. -1445.7. What is the difference between the SF6 emissions (in thousand metric tons of CO2 equivalent) of 2005 in Thailand and the SF6 emissions (in thousand metric tons of CO2 equivalent) of 2008 in Turkey?
Keep it short and to the point. -794.9. What is the average SF6 emissions (in thousand metric tons of CO2 equivalent) of 1990 per country?
Ensure brevity in your answer.  946.52. What is the average SF6 emissions (in thousand metric tons of CO2 equivalent) in 2000 per country?
Offer a terse response. 900.22. What is the average SF6 emissions (in thousand metric tons of CO2 equivalent) of 2005 per country?
Give a very brief answer. 922.08. What is the average SF6 emissions (in thousand metric tons of CO2 equivalent) of 2008 per country?
Ensure brevity in your answer.  1071.12. What is the difference between the SF6 emissions (in thousand metric tons of CO2 equivalent) in 1990 and SF6 emissions (in thousand metric tons of CO2 equivalent) in 2000 in South Africa?
Offer a terse response. 38.5. What is the difference between the SF6 emissions (in thousand metric tons of CO2 equivalent) of 1990 and SF6 emissions (in thousand metric tons of CO2 equivalent) of 2005 in South Africa?
Ensure brevity in your answer.  -465.8. What is the difference between the SF6 emissions (in thousand metric tons of CO2 equivalent) in 1990 and SF6 emissions (in thousand metric tons of CO2 equivalent) in 2008 in South Africa?
Your answer should be compact. -689.7. What is the difference between the SF6 emissions (in thousand metric tons of CO2 equivalent) of 2000 and SF6 emissions (in thousand metric tons of CO2 equivalent) of 2005 in South Africa?
Your answer should be very brief. -504.3. What is the difference between the SF6 emissions (in thousand metric tons of CO2 equivalent) in 2000 and SF6 emissions (in thousand metric tons of CO2 equivalent) in 2008 in South Africa?
Offer a terse response. -728.2. What is the difference between the SF6 emissions (in thousand metric tons of CO2 equivalent) in 2005 and SF6 emissions (in thousand metric tons of CO2 equivalent) in 2008 in South Africa?
Your answer should be very brief. -223.9. What is the difference between the SF6 emissions (in thousand metric tons of CO2 equivalent) in 1990 and SF6 emissions (in thousand metric tons of CO2 equivalent) in 2000 in Spain?
Keep it short and to the point. -2048.2. What is the difference between the SF6 emissions (in thousand metric tons of CO2 equivalent) in 1990 and SF6 emissions (in thousand metric tons of CO2 equivalent) in 2005 in Spain?
Your response must be concise. -335.5. What is the difference between the SF6 emissions (in thousand metric tons of CO2 equivalent) of 1990 and SF6 emissions (in thousand metric tons of CO2 equivalent) of 2008 in Spain?
Make the answer very short. -485.1. What is the difference between the SF6 emissions (in thousand metric tons of CO2 equivalent) in 2000 and SF6 emissions (in thousand metric tons of CO2 equivalent) in 2005 in Spain?
Your answer should be very brief. 1712.7. What is the difference between the SF6 emissions (in thousand metric tons of CO2 equivalent) of 2000 and SF6 emissions (in thousand metric tons of CO2 equivalent) of 2008 in Spain?
Keep it short and to the point. 1563.1. What is the difference between the SF6 emissions (in thousand metric tons of CO2 equivalent) of 2005 and SF6 emissions (in thousand metric tons of CO2 equivalent) of 2008 in Spain?
Keep it short and to the point. -149.6. What is the difference between the SF6 emissions (in thousand metric tons of CO2 equivalent) in 1990 and SF6 emissions (in thousand metric tons of CO2 equivalent) in 2000 in Sweden?
Make the answer very short. -20.5. What is the difference between the SF6 emissions (in thousand metric tons of CO2 equivalent) in 1990 and SF6 emissions (in thousand metric tons of CO2 equivalent) in 2005 in Sweden?
Provide a succinct answer. -40.7. What is the difference between the SF6 emissions (in thousand metric tons of CO2 equivalent) in 2000 and SF6 emissions (in thousand metric tons of CO2 equivalent) in 2005 in Sweden?
Ensure brevity in your answer.  -20.2. What is the difference between the SF6 emissions (in thousand metric tons of CO2 equivalent) in 2000 and SF6 emissions (in thousand metric tons of CO2 equivalent) in 2008 in Sweden?
Make the answer very short. 25.9. What is the difference between the SF6 emissions (in thousand metric tons of CO2 equivalent) of 2005 and SF6 emissions (in thousand metric tons of CO2 equivalent) of 2008 in Sweden?
Give a very brief answer. 46.1. What is the difference between the SF6 emissions (in thousand metric tons of CO2 equivalent) of 1990 and SF6 emissions (in thousand metric tons of CO2 equivalent) of 2000 in Switzerland?
Offer a terse response. 293.7. What is the difference between the SF6 emissions (in thousand metric tons of CO2 equivalent) of 1990 and SF6 emissions (in thousand metric tons of CO2 equivalent) of 2005 in Switzerland?
Provide a short and direct response. 238.1. What is the difference between the SF6 emissions (in thousand metric tons of CO2 equivalent) of 1990 and SF6 emissions (in thousand metric tons of CO2 equivalent) of 2008 in Switzerland?
Your answer should be very brief. 138.5. What is the difference between the SF6 emissions (in thousand metric tons of CO2 equivalent) of 2000 and SF6 emissions (in thousand metric tons of CO2 equivalent) of 2005 in Switzerland?
Provide a short and direct response. -55.6. What is the difference between the SF6 emissions (in thousand metric tons of CO2 equivalent) of 2000 and SF6 emissions (in thousand metric tons of CO2 equivalent) of 2008 in Switzerland?
Give a very brief answer. -155.2. What is the difference between the SF6 emissions (in thousand metric tons of CO2 equivalent) of 2005 and SF6 emissions (in thousand metric tons of CO2 equivalent) of 2008 in Switzerland?
Give a very brief answer. -99.6. What is the difference between the SF6 emissions (in thousand metric tons of CO2 equivalent) in 1990 and SF6 emissions (in thousand metric tons of CO2 equivalent) in 2000 in Thailand?
Your answer should be compact. 976.4. What is the difference between the SF6 emissions (in thousand metric tons of CO2 equivalent) in 1990 and SF6 emissions (in thousand metric tons of CO2 equivalent) in 2005 in Thailand?
Make the answer very short. 325.6. What is the difference between the SF6 emissions (in thousand metric tons of CO2 equivalent) in 1990 and SF6 emissions (in thousand metric tons of CO2 equivalent) in 2008 in Thailand?
Give a very brief answer. 155. What is the difference between the SF6 emissions (in thousand metric tons of CO2 equivalent) in 2000 and SF6 emissions (in thousand metric tons of CO2 equivalent) in 2005 in Thailand?
Your answer should be compact. -650.8. What is the difference between the SF6 emissions (in thousand metric tons of CO2 equivalent) in 2000 and SF6 emissions (in thousand metric tons of CO2 equivalent) in 2008 in Thailand?
Keep it short and to the point. -821.4. What is the difference between the SF6 emissions (in thousand metric tons of CO2 equivalent) in 2005 and SF6 emissions (in thousand metric tons of CO2 equivalent) in 2008 in Thailand?
Provide a short and direct response. -170.6. What is the difference between the SF6 emissions (in thousand metric tons of CO2 equivalent) in 1990 and SF6 emissions (in thousand metric tons of CO2 equivalent) in 2000 in Turkey?
Your answer should be compact. 1037.9. What is the difference between the SF6 emissions (in thousand metric tons of CO2 equivalent) of 1990 and SF6 emissions (in thousand metric tons of CO2 equivalent) of 2005 in Turkey?
Your answer should be compact. 424.9. What is the difference between the SF6 emissions (in thousand metric tons of CO2 equivalent) in 1990 and SF6 emissions (in thousand metric tons of CO2 equivalent) in 2008 in Turkey?
Your answer should be compact. 128.3. What is the difference between the SF6 emissions (in thousand metric tons of CO2 equivalent) in 2000 and SF6 emissions (in thousand metric tons of CO2 equivalent) in 2005 in Turkey?
Offer a terse response. -613. What is the difference between the SF6 emissions (in thousand metric tons of CO2 equivalent) of 2000 and SF6 emissions (in thousand metric tons of CO2 equivalent) of 2008 in Turkey?
Provide a succinct answer. -909.6. What is the difference between the SF6 emissions (in thousand metric tons of CO2 equivalent) in 2005 and SF6 emissions (in thousand metric tons of CO2 equivalent) in 2008 in Turkey?
Ensure brevity in your answer.  -296.6. What is the ratio of the SF6 emissions (in thousand metric tons of CO2 equivalent) of 1990 in South Africa to that in Spain?
Your answer should be very brief. 2.58. What is the ratio of the SF6 emissions (in thousand metric tons of CO2 equivalent) of 2000 in South Africa to that in Spain?
Offer a terse response. 0.41. What is the ratio of the SF6 emissions (in thousand metric tons of CO2 equivalent) in 2005 in South Africa to that in Spain?
Provide a short and direct response. 2.04. What is the ratio of the SF6 emissions (in thousand metric tons of CO2 equivalent) of 2008 in South Africa to that in Spain?
Ensure brevity in your answer.  1.95. What is the ratio of the SF6 emissions (in thousand metric tons of CO2 equivalent) in 1990 in South Africa to that in Sweden?
Provide a short and direct response. 6.07. What is the ratio of the SF6 emissions (in thousand metric tons of CO2 equivalent) of 2000 in South Africa to that in Sweden?
Offer a terse response. 5.23. What is the ratio of the SF6 emissions (in thousand metric tons of CO2 equivalent) in 2005 in South Africa to that in Sweden?
Your response must be concise. 7.09. What is the ratio of the SF6 emissions (in thousand metric tons of CO2 equivalent) in 2008 in South Africa to that in Sweden?
Provide a succinct answer. 10.37. What is the ratio of the SF6 emissions (in thousand metric tons of CO2 equivalent) of 1990 in South Africa to that in Switzerland?
Make the answer very short. 1.8. What is the ratio of the SF6 emissions (in thousand metric tons of CO2 equivalent) in 2000 in South Africa to that in Switzerland?
Give a very brief answer. 3.46. What is the ratio of the SF6 emissions (in thousand metric tons of CO2 equivalent) of 2005 in South Africa to that in Switzerland?
Provide a succinct answer. 4.36. What is the ratio of the SF6 emissions (in thousand metric tons of CO2 equivalent) in 2008 in South Africa to that in Switzerland?
Ensure brevity in your answer.  3.89. What is the ratio of the SF6 emissions (in thousand metric tons of CO2 equivalent) in 1990 in South Africa to that in Thailand?
Offer a very short reply. 0.74. What is the ratio of the SF6 emissions (in thousand metric tons of CO2 equivalent) in 2000 in South Africa to that in Thailand?
Make the answer very short. 2.24. What is the ratio of the SF6 emissions (in thousand metric tons of CO2 equivalent) in 2005 in South Africa to that in Thailand?
Make the answer very short. 1.38. What is the ratio of the SF6 emissions (in thousand metric tons of CO2 equivalent) in 2008 in South Africa to that in Thailand?
Your answer should be very brief. 1.37. What is the ratio of the SF6 emissions (in thousand metric tons of CO2 equivalent) in 1990 in South Africa to that in Turkey?
Your answer should be compact. 0.52. What is the ratio of the SF6 emissions (in thousand metric tons of CO2 equivalent) of 2000 in South Africa to that in Turkey?
Your answer should be compact. 1.03. What is the ratio of the SF6 emissions (in thousand metric tons of CO2 equivalent) of 2005 in South Africa to that in Turkey?
Offer a very short reply. 0.95. What is the ratio of the SF6 emissions (in thousand metric tons of CO2 equivalent) of 2008 in South Africa to that in Turkey?
Ensure brevity in your answer.  0.92. What is the ratio of the SF6 emissions (in thousand metric tons of CO2 equivalent) in 1990 in Spain to that in Sweden?
Your response must be concise. 2.35. What is the ratio of the SF6 emissions (in thousand metric tons of CO2 equivalent) in 2000 in Spain to that in Sweden?
Make the answer very short. 12.66. What is the ratio of the SF6 emissions (in thousand metric tons of CO2 equivalent) in 2005 in Spain to that in Sweden?
Give a very brief answer. 3.47. What is the ratio of the SF6 emissions (in thousand metric tons of CO2 equivalent) of 2008 in Spain to that in Sweden?
Offer a terse response. 5.31. What is the ratio of the SF6 emissions (in thousand metric tons of CO2 equivalent) in 1990 in Spain to that in Switzerland?
Keep it short and to the point. 0.7. What is the ratio of the SF6 emissions (in thousand metric tons of CO2 equivalent) of 2000 in Spain to that in Switzerland?
Your answer should be very brief. 8.38. What is the ratio of the SF6 emissions (in thousand metric tons of CO2 equivalent) of 2005 in Spain to that in Switzerland?
Offer a very short reply. 2.13. What is the ratio of the SF6 emissions (in thousand metric tons of CO2 equivalent) in 2008 in Spain to that in Switzerland?
Provide a short and direct response. 1.99. What is the ratio of the SF6 emissions (in thousand metric tons of CO2 equivalent) of 1990 in Spain to that in Thailand?
Keep it short and to the point. 0.29. What is the ratio of the SF6 emissions (in thousand metric tons of CO2 equivalent) of 2000 in Spain to that in Thailand?
Give a very brief answer. 5.42. What is the ratio of the SF6 emissions (in thousand metric tons of CO2 equivalent) in 2005 in Spain to that in Thailand?
Offer a terse response. 0.67. What is the ratio of the SF6 emissions (in thousand metric tons of CO2 equivalent) in 2008 in Spain to that in Thailand?
Keep it short and to the point. 0.7. What is the ratio of the SF6 emissions (in thousand metric tons of CO2 equivalent) in 1990 in Spain to that in Turkey?
Provide a short and direct response. 0.2. What is the ratio of the SF6 emissions (in thousand metric tons of CO2 equivalent) of 2000 in Spain to that in Turkey?
Ensure brevity in your answer.  2.48. What is the ratio of the SF6 emissions (in thousand metric tons of CO2 equivalent) in 2005 in Spain to that in Turkey?
Ensure brevity in your answer.  0.46. What is the ratio of the SF6 emissions (in thousand metric tons of CO2 equivalent) in 2008 in Spain to that in Turkey?
Offer a very short reply. 0.47. What is the ratio of the SF6 emissions (in thousand metric tons of CO2 equivalent) in 1990 in Sweden to that in Switzerland?
Offer a terse response. 0.3. What is the ratio of the SF6 emissions (in thousand metric tons of CO2 equivalent) of 2000 in Sweden to that in Switzerland?
Provide a short and direct response. 0.66. What is the ratio of the SF6 emissions (in thousand metric tons of CO2 equivalent) of 2005 in Sweden to that in Switzerland?
Give a very brief answer. 0.61. What is the ratio of the SF6 emissions (in thousand metric tons of CO2 equivalent) of 1990 in Sweden to that in Thailand?
Give a very brief answer. 0.12. What is the ratio of the SF6 emissions (in thousand metric tons of CO2 equivalent) in 2000 in Sweden to that in Thailand?
Provide a succinct answer. 0.43. What is the ratio of the SF6 emissions (in thousand metric tons of CO2 equivalent) of 2005 in Sweden to that in Thailand?
Make the answer very short. 0.19. What is the ratio of the SF6 emissions (in thousand metric tons of CO2 equivalent) of 2008 in Sweden to that in Thailand?
Provide a succinct answer. 0.13. What is the ratio of the SF6 emissions (in thousand metric tons of CO2 equivalent) in 1990 in Sweden to that in Turkey?
Give a very brief answer. 0.09. What is the ratio of the SF6 emissions (in thousand metric tons of CO2 equivalent) of 2000 in Sweden to that in Turkey?
Make the answer very short. 0.2. What is the ratio of the SF6 emissions (in thousand metric tons of CO2 equivalent) in 2005 in Sweden to that in Turkey?
Provide a succinct answer. 0.13. What is the ratio of the SF6 emissions (in thousand metric tons of CO2 equivalent) of 2008 in Sweden to that in Turkey?
Ensure brevity in your answer.  0.09. What is the ratio of the SF6 emissions (in thousand metric tons of CO2 equivalent) in 1990 in Switzerland to that in Thailand?
Give a very brief answer. 0.41. What is the ratio of the SF6 emissions (in thousand metric tons of CO2 equivalent) of 2000 in Switzerland to that in Thailand?
Your response must be concise. 0.65. What is the ratio of the SF6 emissions (in thousand metric tons of CO2 equivalent) in 2005 in Switzerland to that in Thailand?
Offer a terse response. 0.32. What is the ratio of the SF6 emissions (in thousand metric tons of CO2 equivalent) of 2008 in Switzerland to that in Thailand?
Provide a succinct answer. 0.35. What is the ratio of the SF6 emissions (in thousand metric tons of CO2 equivalent) of 1990 in Switzerland to that in Turkey?
Provide a short and direct response. 0.29. What is the ratio of the SF6 emissions (in thousand metric tons of CO2 equivalent) in 2000 in Switzerland to that in Turkey?
Provide a short and direct response. 0.3. What is the ratio of the SF6 emissions (in thousand metric tons of CO2 equivalent) of 2005 in Switzerland to that in Turkey?
Offer a very short reply. 0.22. What is the ratio of the SF6 emissions (in thousand metric tons of CO2 equivalent) in 2008 in Switzerland to that in Turkey?
Ensure brevity in your answer.  0.24. What is the ratio of the SF6 emissions (in thousand metric tons of CO2 equivalent) in 1990 in Thailand to that in Turkey?
Your answer should be compact. 0.71. What is the ratio of the SF6 emissions (in thousand metric tons of CO2 equivalent) in 2000 in Thailand to that in Turkey?
Keep it short and to the point. 0.46. What is the ratio of the SF6 emissions (in thousand metric tons of CO2 equivalent) of 2005 in Thailand to that in Turkey?
Offer a terse response. 0.69. What is the ratio of the SF6 emissions (in thousand metric tons of CO2 equivalent) in 2008 in Thailand to that in Turkey?
Ensure brevity in your answer.  0.67. What is the difference between the highest and the second highest SF6 emissions (in thousand metric tons of CO2 equivalent) in 1990?
Offer a terse response. 597.6. What is the difference between the highest and the second highest SF6 emissions (in thousand metric tons of CO2 equivalent) of 2000?
Offer a terse response. 1441.1. What is the difference between the highest and the second highest SF6 emissions (in thousand metric tons of CO2 equivalent) of 2005?
Keep it short and to the point. 82.5. What is the difference between the highest and the second highest SF6 emissions (in thousand metric tons of CO2 equivalent) in 2008?
Provide a short and direct response. 155.2. What is the difference between the highest and the lowest SF6 emissions (in thousand metric tons of CO2 equivalent) of 1990?
Make the answer very short. 1853.6. What is the difference between the highest and the lowest SF6 emissions (in thousand metric tons of CO2 equivalent) of 2000?
Give a very brief answer. 2262.5. What is the difference between the highest and the lowest SF6 emissions (in thousand metric tons of CO2 equivalent) in 2005?
Your answer should be compact. 1388. What is the difference between the highest and the lowest SF6 emissions (in thousand metric tons of CO2 equivalent) in 2008?
Offer a terse response. 1730.7. 